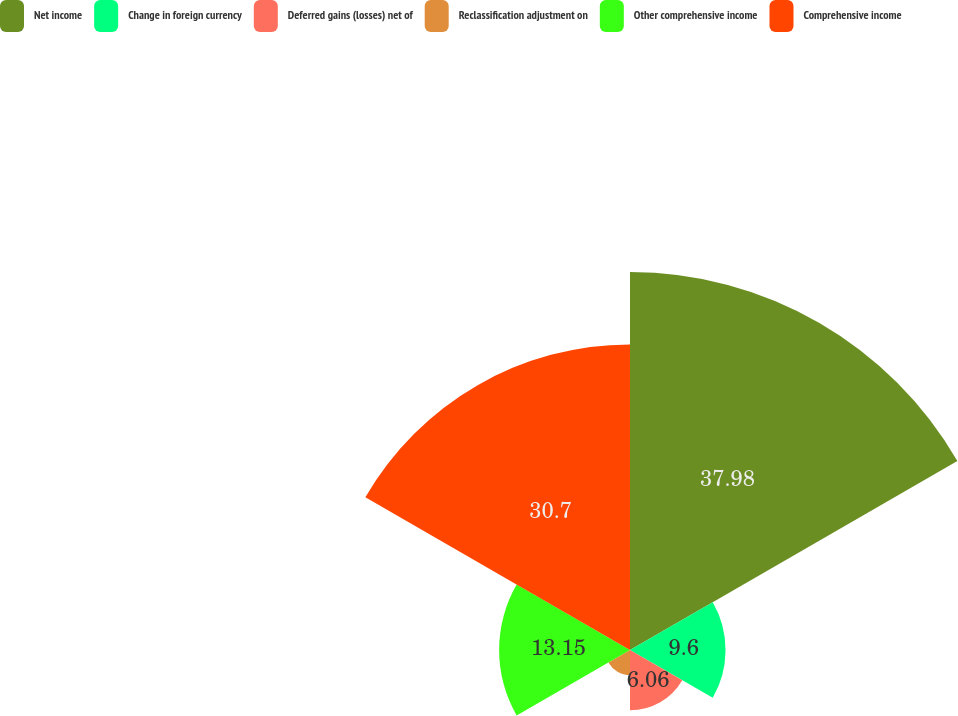<chart> <loc_0><loc_0><loc_500><loc_500><pie_chart><fcel>Net income<fcel>Change in foreign currency<fcel>Deferred gains (losses) net of<fcel>Reclassification adjustment on<fcel>Other comprehensive income<fcel>Comprehensive income<nl><fcel>37.98%<fcel>9.6%<fcel>6.06%<fcel>2.51%<fcel>13.15%<fcel>30.7%<nl></chart> 